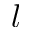<formula> <loc_0><loc_0><loc_500><loc_500>l</formula> 